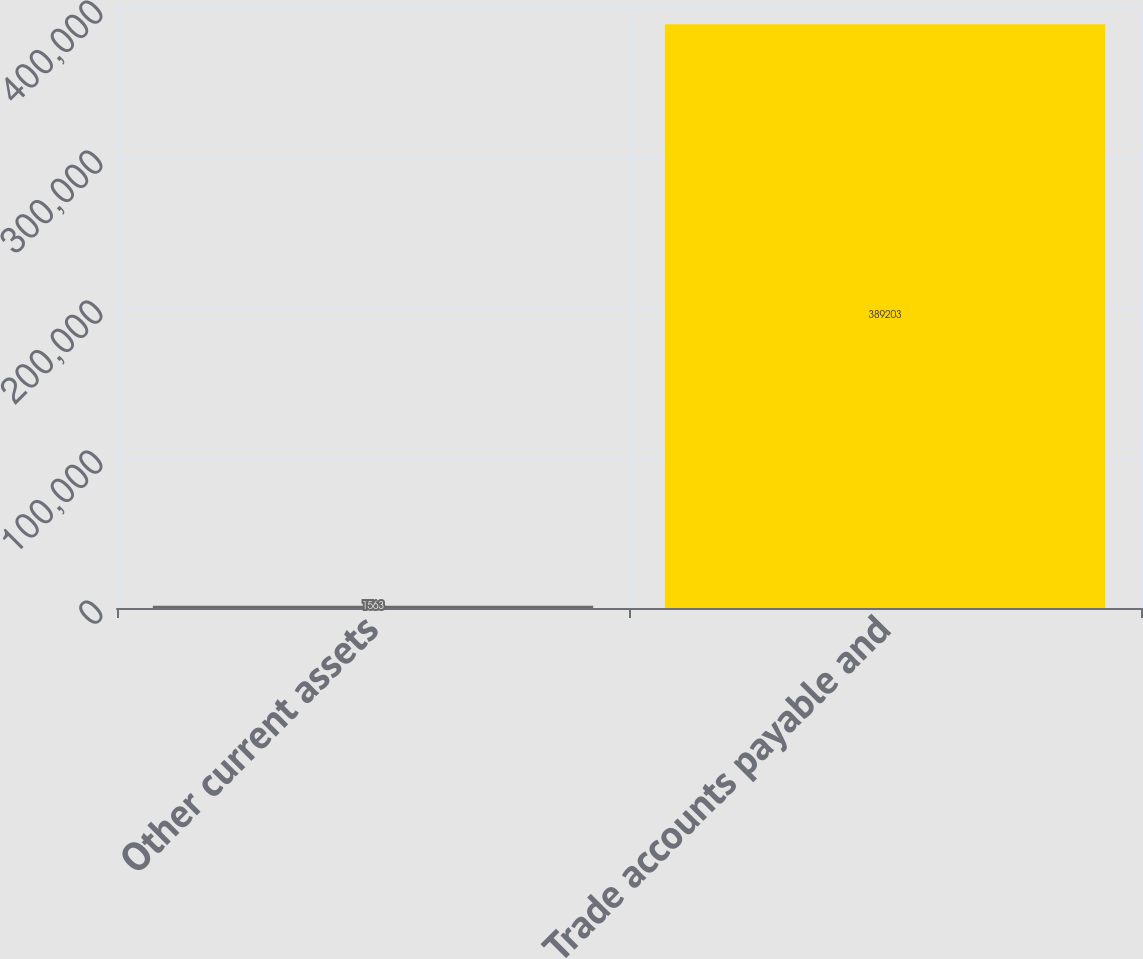Convert chart to OTSL. <chart><loc_0><loc_0><loc_500><loc_500><bar_chart><fcel>Other current assets<fcel>Trade accounts payable and<nl><fcel>1563<fcel>389203<nl></chart> 